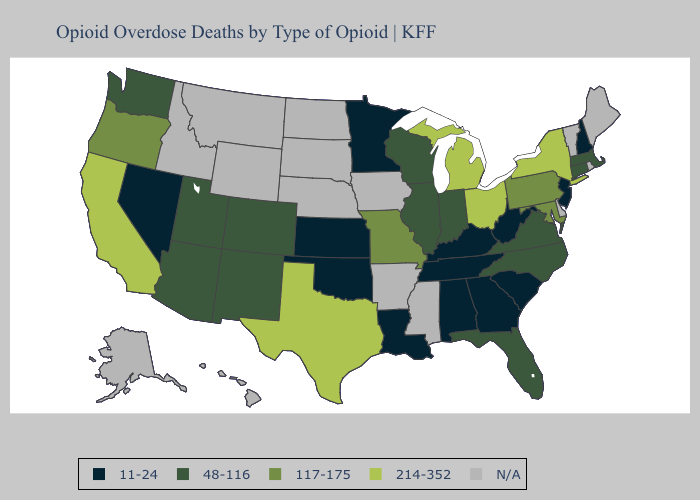What is the value of Nebraska?
Short answer required. N/A. Name the states that have a value in the range 11-24?
Give a very brief answer. Alabama, Georgia, Kansas, Kentucky, Louisiana, Minnesota, Nevada, New Hampshire, New Jersey, Oklahoma, South Carolina, Tennessee, West Virginia. Among the states that border Alabama , which have the highest value?
Be succinct. Florida. What is the highest value in states that border Nevada?
Give a very brief answer. 214-352. What is the highest value in states that border South Carolina?
Write a very short answer. 48-116. Name the states that have a value in the range 214-352?
Be succinct. California, Michigan, New York, Ohio, Texas. Name the states that have a value in the range 214-352?
Be succinct. California, Michigan, New York, Ohio, Texas. Name the states that have a value in the range 48-116?
Quick response, please. Arizona, Colorado, Connecticut, Florida, Illinois, Indiana, Massachusetts, New Mexico, North Carolina, Utah, Virginia, Washington, Wisconsin. Does Connecticut have the lowest value in the USA?
Be succinct. No. Does the map have missing data?
Give a very brief answer. Yes. Among the states that border Mississippi , which have the highest value?
Concise answer only. Alabama, Louisiana, Tennessee. Name the states that have a value in the range N/A?
Keep it brief. Alaska, Arkansas, Delaware, Hawaii, Idaho, Iowa, Maine, Mississippi, Montana, Nebraska, North Dakota, Rhode Island, South Dakota, Vermont, Wyoming. 